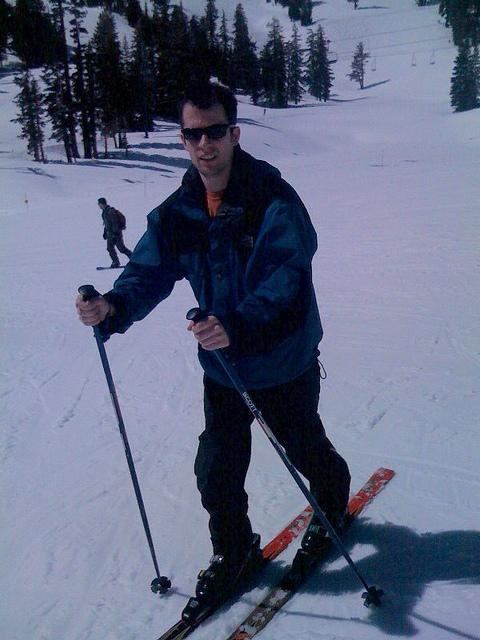What is the man in the foreground balancing with? Please explain your reasoning. ski poles. He is holding two long metal sticks that help him while he skis 